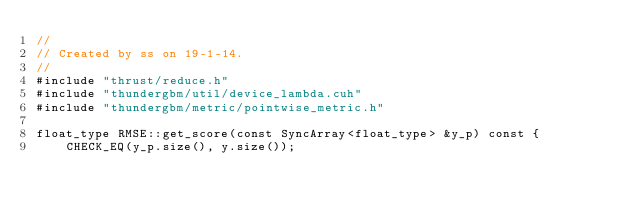<code> <loc_0><loc_0><loc_500><loc_500><_Cuda_>//
// Created by ss on 19-1-14.
//
#include "thrust/reduce.h"
#include "thundergbm/util/device_lambda.cuh"
#include "thundergbm/metric/pointwise_metric.h"

float_type RMSE::get_score(const SyncArray<float_type> &y_p) const {
    CHECK_EQ(y_p.size(), y.size());</code> 